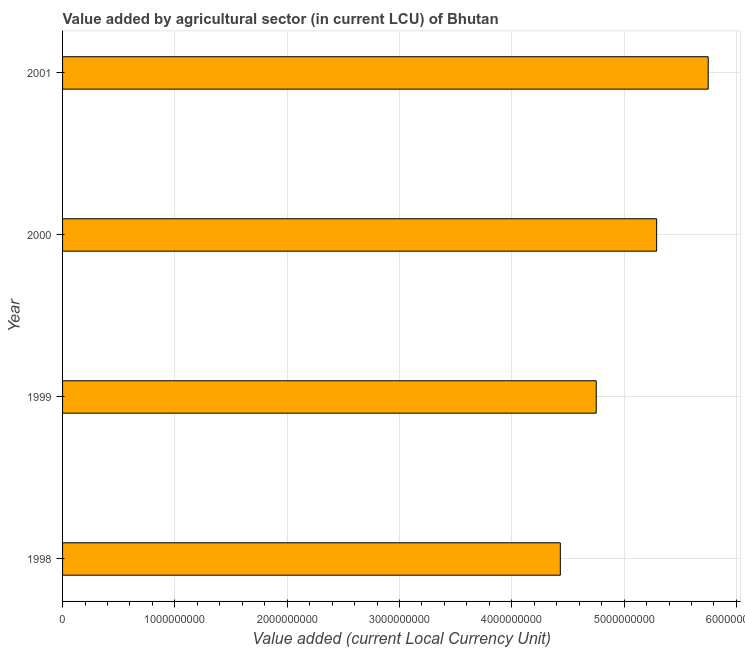Does the graph contain any zero values?
Provide a succinct answer. No. What is the title of the graph?
Ensure brevity in your answer.  Value added by agricultural sector (in current LCU) of Bhutan. What is the label or title of the X-axis?
Give a very brief answer. Value added (current Local Currency Unit). What is the label or title of the Y-axis?
Your response must be concise. Year. What is the value added by agriculture sector in 2001?
Give a very brief answer. 5.75e+09. Across all years, what is the maximum value added by agriculture sector?
Provide a short and direct response. 5.75e+09. Across all years, what is the minimum value added by agriculture sector?
Offer a very short reply. 4.43e+09. In which year was the value added by agriculture sector minimum?
Your answer should be compact. 1998. What is the sum of the value added by agriculture sector?
Ensure brevity in your answer.  2.02e+1. What is the difference between the value added by agriculture sector in 1998 and 2001?
Give a very brief answer. -1.32e+09. What is the average value added by agriculture sector per year?
Give a very brief answer. 5.06e+09. What is the median value added by agriculture sector?
Your answer should be very brief. 5.02e+09. In how many years, is the value added by agriculture sector greater than 1800000000 LCU?
Your answer should be very brief. 4. What is the ratio of the value added by agriculture sector in 1999 to that in 2001?
Offer a terse response. 0.83. Is the difference between the value added by agriculture sector in 2000 and 2001 greater than the difference between any two years?
Your answer should be compact. No. What is the difference between the highest and the second highest value added by agriculture sector?
Your response must be concise. 4.59e+08. Is the sum of the value added by agriculture sector in 1998 and 2000 greater than the maximum value added by agriculture sector across all years?
Your answer should be very brief. Yes. What is the difference between the highest and the lowest value added by agriculture sector?
Your response must be concise. 1.32e+09. How many years are there in the graph?
Your answer should be very brief. 4. What is the difference between two consecutive major ticks on the X-axis?
Your answer should be very brief. 1.00e+09. Are the values on the major ticks of X-axis written in scientific E-notation?
Keep it short and to the point. No. What is the Value added (current Local Currency Unit) of 1998?
Your answer should be very brief. 4.43e+09. What is the Value added (current Local Currency Unit) of 1999?
Keep it short and to the point. 4.75e+09. What is the Value added (current Local Currency Unit) of 2000?
Offer a very short reply. 5.29e+09. What is the Value added (current Local Currency Unit) in 2001?
Your answer should be compact. 5.75e+09. What is the difference between the Value added (current Local Currency Unit) in 1998 and 1999?
Your answer should be compact. -3.20e+08. What is the difference between the Value added (current Local Currency Unit) in 1998 and 2000?
Give a very brief answer. -8.58e+08. What is the difference between the Value added (current Local Currency Unit) in 1998 and 2001?
Give a very brief answer. -1.32e+09. What is the difference between the Value added (current Local Currency Unit) in 1999 and 2000?
Your response must be concise. -5.38e+08. What is the difference between the Value added (current Local Currency Unit) in 1999 and 2001?
Keep it short and to the point. -9.97e+08. What is the difference between the Value added (current Local Currency Unit) in 2000 and 2001?
Provide a short and direct response. -4.59e+08. What is the ratio of the Value added (current Local Currency Unit) in 1998 to that in 1999?
Provide a short and direct response. 0.93. What is the ratio of the Value added (current Local Currency Unit) in 1998 to that in 2000?
Keep it short and to the point. 0.84. What is the ratio of the Value added (current Local Currency Unit) in 1998 to that in 2001?
Provide a succinct answer. 0.77. What is the ratio of the Value added (current Local Currency Unit) in 1999 to that in 2000?
Your answer should be compact. 0.9. What is the ratio of the Value added (current Local Currency Unit) in 1999 to that in 2001?
Offer a very short reply. 0.83. What is the ratio of the Value added (current Local Currency Unit) in 2000 to that in 2001?
Provide a short and direct response. 0.92. 